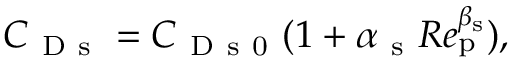Convert formula to latex. <formula><loc_0><loc_0><loc_500><loc_500>C _ { D s } = C _ { D s 0 } ( 1 + \alpha _ { s } R e _ { p } ^ { \beta _ { s } } ) ,</formula> 